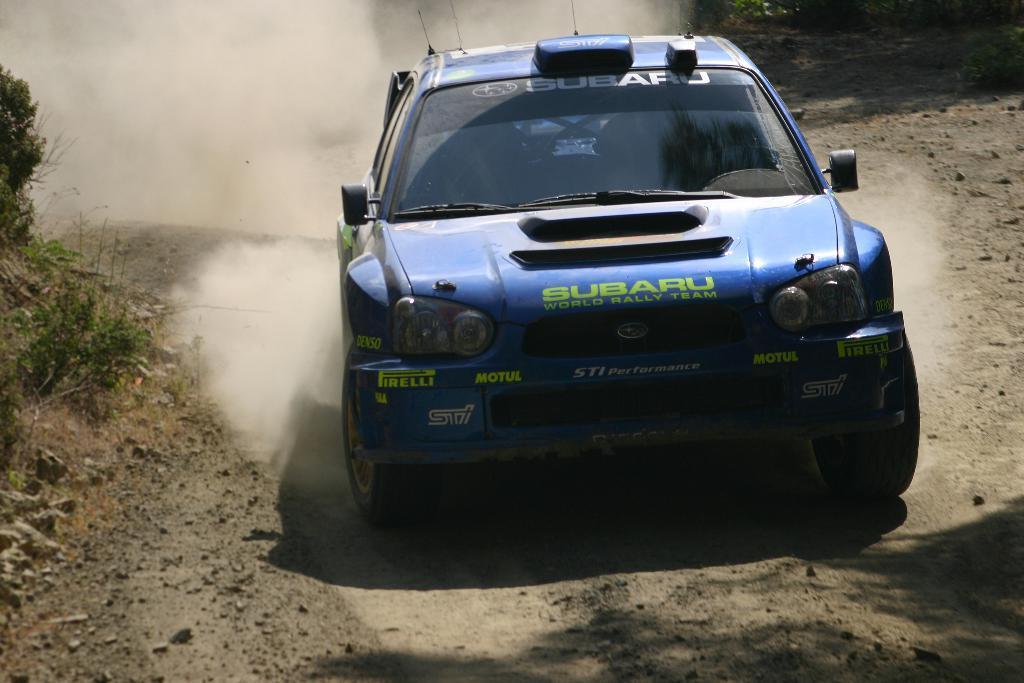How would you summarize this image in a sentence or two? In the foreground of this image, there is a sports car on the ground and in the background, we can see smoke and plants. 